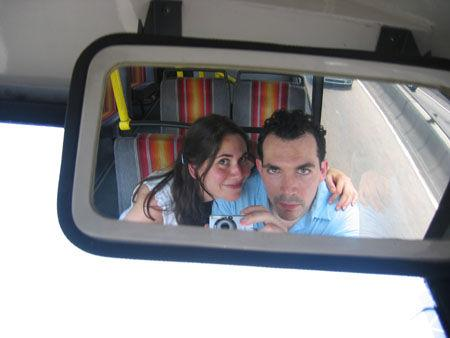They are taking this photo in what?

Choices:
A) bus
B) car
C) train
D) airplane bus 